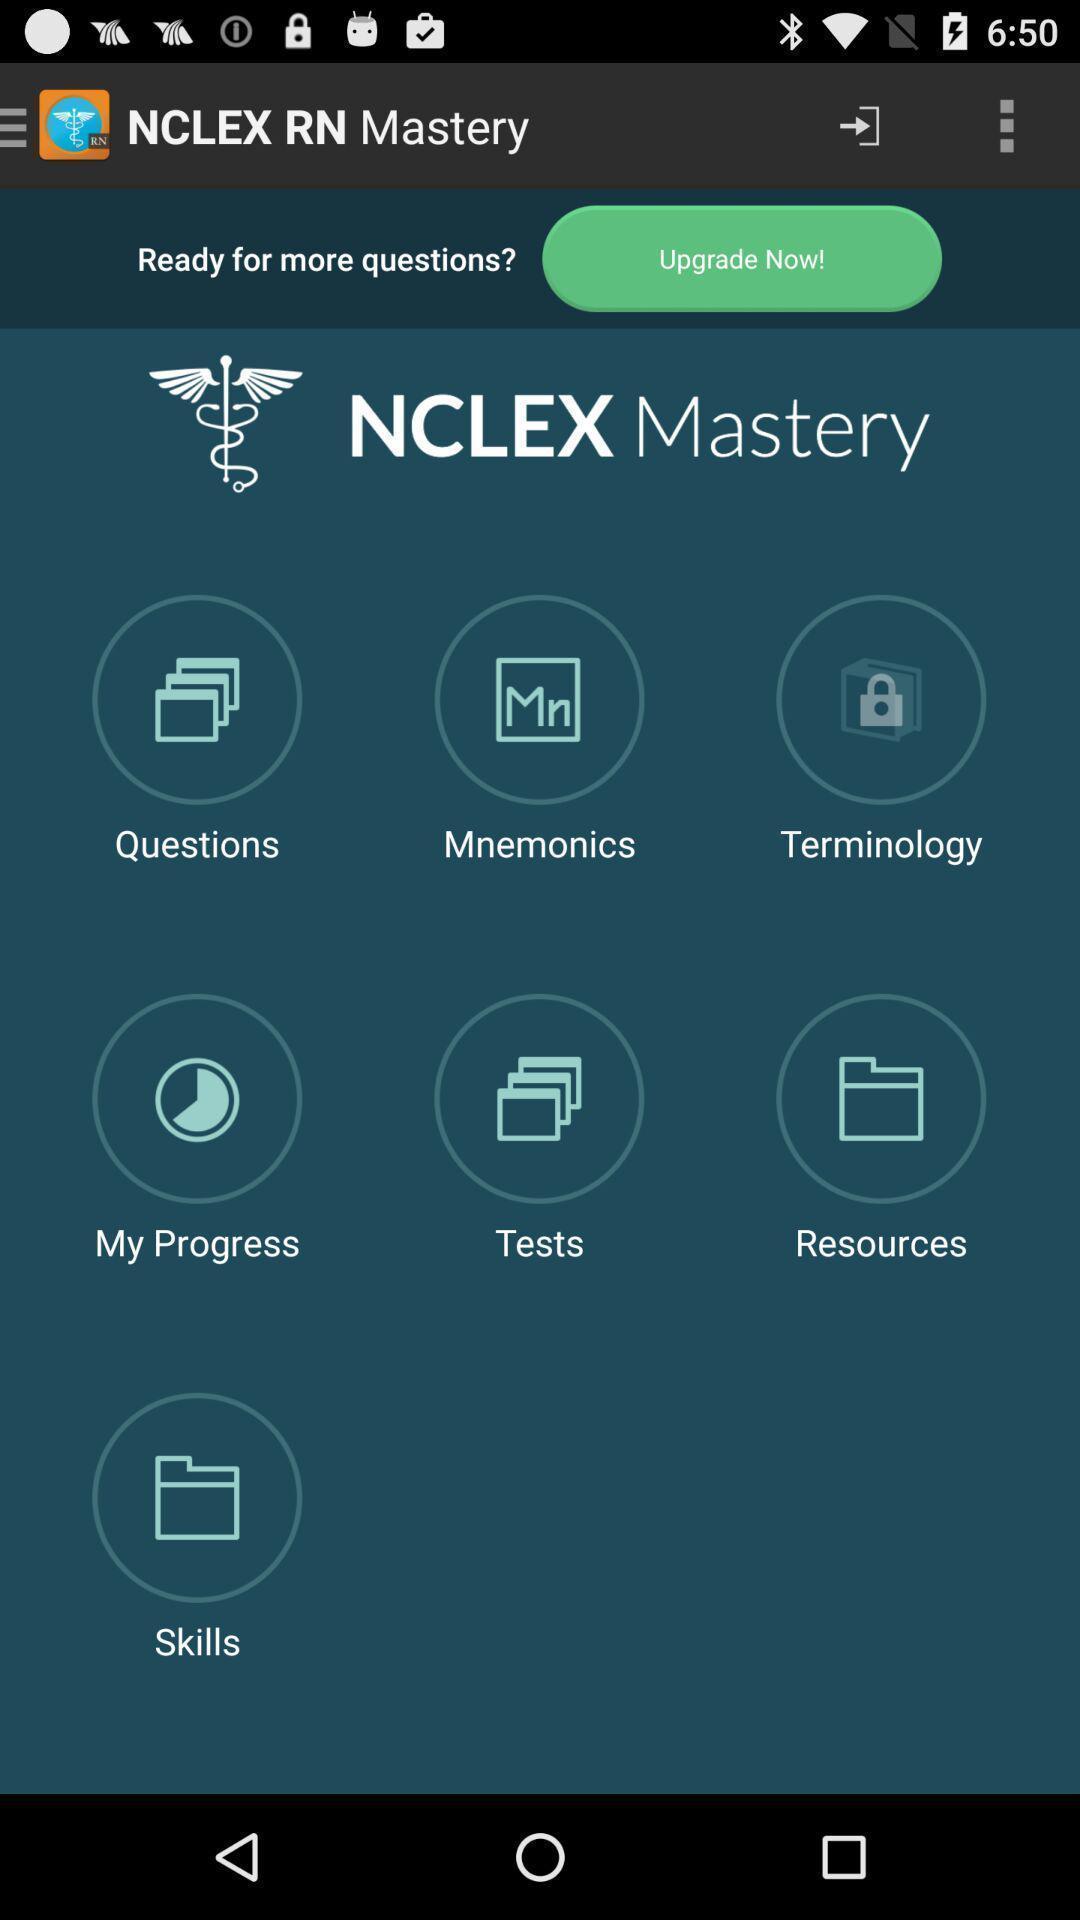Explain what's happening in this screen capture. Screen shows mastery options. 